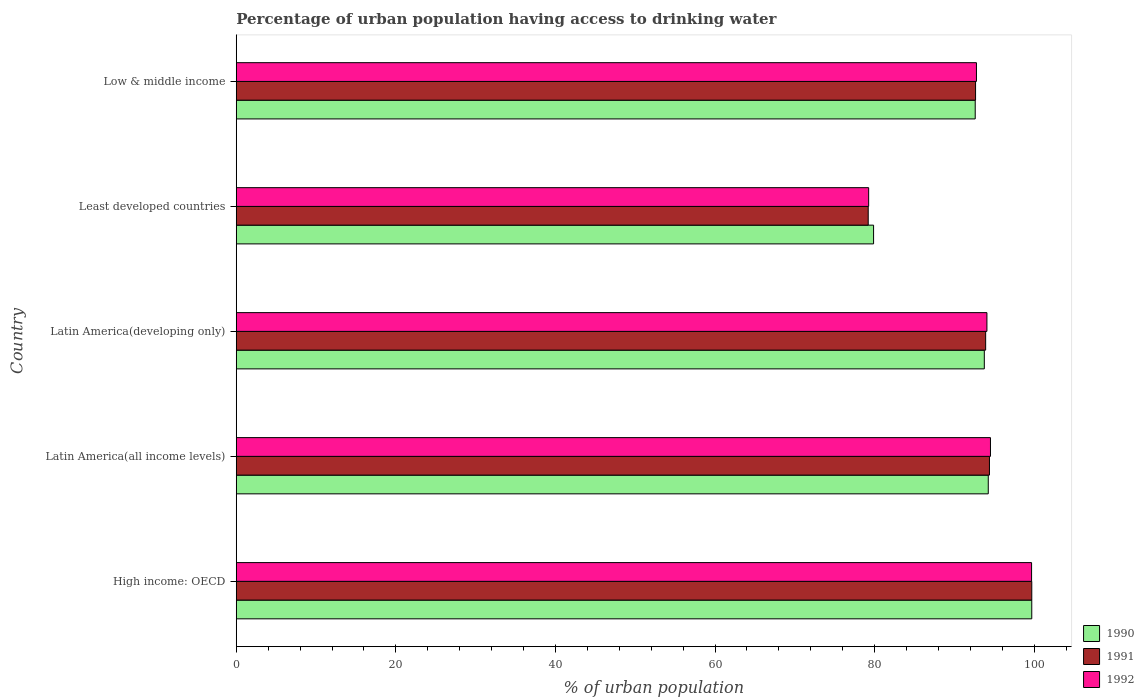How many different coloured bars are there?
Provide a short and direct response. 3. How many groups of bars are there?
Ensure brevity in your answer.  5. Are the number of bars on each tick of the Y-axis equal?
Provide a short and direct response. Yes. What is the label of the 2nd group of bars from the top?
Your answer should be compact. Least developed countries. In how many cases, is the number of bars for a given country not equal to the number of legend labels?
Ensure brevity in your answer.  0. What is the percentage of urban population having access to drinking water in 1990 in Latin America(developing only)?
Provide a succinct answer. 93.75. Across all countries, what is the maximum percentage of urban population having access to drinking water in 1992?
Give a very brief answer. 99.67. Across all countries, what is the minimum percentage of urban population having access to drinking water in 1990?
Ensure brevity in your answer.  79.87. In which country was the percentage of urban population having access to drinking water in 1992 maximum?
Offer a terse response. High income: OECD. In which country was the percentage of urban population having access to drinking water in 1990 minimum?
Offer a terse response. Least developed countries. What is the total percentage of urban population having access to drinking water in 1990 in the graph?
Your response must be concise. 460.16. What is the difference between the percentage of urban population having access to drinking water in 1990 in Latin America(developing only) and that in Least developed countries?
Give a very brief answer. 13.88. What is the difference between the percentage of urban population having access to drinking water in 1991 in Low & middle income and the percentage of urban population having access to drinking water in 1992 in Least developed countries?
Ensure brevity in your answer.  13.4. What is the average percentage of urban population having access to drinking water in 1990 per country?
Give a very brief answer. 92.03. What is the difference between the percentage of urban population having access to drinking water in 1992 and percentage of urban population having access to drinking water in 1991 in High income: OECD?
Your answer should be very brief. -0.02. What is the ratio of the percentage of urban population having access to drinking water in 1990 in High income: OECD to that in Least developed countries?
Make the answer very short. 1.25. Is the percentage of urban population having access to drinking water in 1992 in Latin America(all income levels) less than that in Latin America(developing only)?
Your answer should be very brief. No. What is the difference between the highest and the second highest percentage of urban population having access to drinking water in 1991?
Keep it short and to the point. 5.31. What is the difference between the highest and the lowest percentage of urban population having access to drinking water in 1990?
Give a very brief answer. 19.82. In how many countries, is the percentage of urban population having access to drinking water in 1990 greater than the average percentage of urban population having access to drinking water in 1990 taken over all countries?
Provide a succinct answer. 4. Is the sum of the percentage of urban population having access to drinking water in 1991 in High income: OECD and Least developed countries greater than the maximum percentage of urban population having access to drinking water in 1992 across all countries?
Give a very brief answer. Yes. What does the 1st bar from the top in Latin America(developing only) represents?
Give a very brief answer. 1992. What does the 1st bar from the bottom in High income: OECD represents?
Your answer should be very brief. 1990. What is the difference between two consecutive major ticks on the X-axis?
Give a very brief answer. 20. Are the values on the major ticks of X-axis written in scientific E-notation?
Ensure brevity in your answer.  No. Where does the legend appear in the graph?
Keep it short and to the point. Bottom right. How many legend labels are there?
Offer a very short reply. 3. How are the legend labels stacked?
Keep it short and to the point. Vertical. What is the title of the graph?
Your answer should be compact. Percentage of urban population having access to drinking water. What is the label or title of the X-axis?
Keep it short and to the point. % of urban population. What is the label or title of the Y-axis?
Offer a very short reply. Country. What is the % of urban population of 1990 in High income: OECD?
Make the answer very short. 99.69. What is the % of urban population in 1991 in High income: OECD?
Your answer should be very brief. 99.7. What is the % of urban population of 1992 in High income: OECD?
Your answer should be compact. 99.67. What is the % of urban population of 1990 in Latin America(all income levels)?
Provide a short and direct response. 94.24. What is the % of urban population of 1991 in Latin America(all income levels)?
Offer a very short reply. 94.39. What is the % of urban population in 1992 in Latin America(all income levels)?
Offer a very short reply. 94.52. What is the % of urban population of 1990 in Latin America(developing only)?
Make the answer very short. 93.75. What is the % of urban population in 1991 in Latin America(developing only)?
Your response must be concise. 93.92. What is the % of urban population in 1992 in Latin America(developing only)?
Provide a short and direct response. 94.07. What is the % of urban population of 1990 in Least developed countries?
Your answer should be very brief. 79.87. What is the % of urban population of 1991 in Least developed countries?
Offer a terse response. 79.2. What is the % of urban population in 1992 in Least developed countries?
Provide a succinct answer. 79.25. What is the % of urban population in 1990 in Low & middle income?
Give a very brief answer. 92.61. What is the % of urban population of 1991 in Low & middle income?
Your answer should be compact. 92.65. What is the % of urban population of 1992 in Low & middle income?
Provide a short and direct response. 92.76. Across all countries, what is the maximum % of urban population of 1990?
Give a very brief answer. 99.69. Across all countries, what is the maximum % of urban population of 1991?
Make the answer very short. 99.7. Across all countries, what is the maximum % of urban population of 1992?
Give a very brief answer. 99.67. Across all countries, what is the minimum % of urban population of 1990?
Your answer should be very brief. 79.87. Across all countries, what is the minimum % of urban population of 1991?
Make the answer very short. 79.2. Across all countries, what is the minimum % of urban population of 1992?
Make the answer very short. 79.25. What is the total % of urban population in 1990 in the graph?
Your response must be concise. 460.16. What is the total % of urban population in 1991 in the graph?
Keep it short and to the point. 459.85. What is the total % of urban population of 1992 in the graph?
Keep it short and to the point. 460.28. What is the difference between the % of urban population of 1990 in High income: OECD and that in Latin America(all income levels)?
Offer a very short reply. 5.45. What is the difference between the % of urban population of 1991 in High income: OECD and that in Latin America(all income levels)?
Your answer should be very brief. 5.31. What is the difference between the % of urban population in 1992 in High income: OECD and that in Latin America(all income levels)?
Give a very brief answer. 5.15. What is the difference between the % of urban population of 1990 in High income: OECD and that in Latin America(developing only)?
Make the answer very short. 5.95. What is the difference between the % of urban population in 1991 in High income: OECD and that in Latin America(developing only)?
Your answer should be compact. 5.78. What is the difference between the % of urban population of 1992 in High income: OECD and that in Latin America(developing only)?
Your response must be concise. 5.6. What is the difference between the % of urban population in 1990 in High income: OECD and that in Least developed countries?
Give a very brief answer. 19.82. What is the difference between the % of urban population in 1991 in High income: OECD and that in Least developed countries?
Offer a very short reply. 20.5. What is the difference between the % of urban population in 1992 in High income: OECD and that in Least developed countries?
Your answer should be compact. 20.42. What is the difference between the % of urban population of 1990 in High income: OECD and that in Low & middle income?
Ensure brevity in your answer.  7.09. What is the difference between the % of urban population of 1991 in High income: OECD and that in Low & middle income?
Your answer should be very brief. 7.05. What is the difference between the % of urban population in 1992 in High income: OECD and that in Low & middle income?
Make the answer very short. 6.91. What is the difference between the % of urban population of 1990 in Latin America(all income levels) and that in Latin America(developing only)?
Keep it short and to the point. 0.49. What is the difference between the % of urban population in 1991 in Latin America(all income levels) and that in Latin America(developing only)?
Provide a succinct answer. 0.47. What is the difference between the % of urban population in 1992 in Latin America(all income levels) and that in Latin America(developing only)?
Provide a short and direct response. 0.44. What is the difference between the % of urban population in 1990 in Latin America(all income levels) and that in Least developed countries?
Offer a terse response. 14.37. What is the difference between the % of urban population of 1991 in Latin America(all income levels) and that in Least developed countries?
Offer a very short reply. 15.19. What is the difference between the % of urban population of 1992 in Latin America(all income levels) and that in Least developed countries?
Offer a very short reply. 15.27. What is the difference between the % of urban population in 1990 in Latin America(all income levels) and that in Low & middle income?
Your answer should be very brief. 1.63. What is the difference between the % of urban population in 1991 in Latin America(all income levels) and that in Low & middle income?
Make the answer very short. 1.74. What is the difference between the % of urban population in 1992 in Latin America(all income levels) and that in Low & middle income?
Offer a terse response. 1.76. What is the difference between the % of urban population of 1990 in Latin America(developing only) and that in Least developed countries?
Offer a terse response. 13.88. What is the difference between the % of urban population of 1991 in Latin America(developing only) and that in Least developed countries?
Provide a short and direct response. 14.72. What is the difference between the % of urban population in 1992 in Latin America(developing only) and that in Least developed countries?
Offer a terse response. 14.82. What is the difference between the % of urban population of 1990 in Latin America(developing only) and that in Low & middle income?
Your answer should be compact. 1.14. What is the difference between the % of urban population of 1991 in Latin America(developing only) and that in Low & middle income?
Provide a succinct answer. 1.27. What is the difference between the % of urban population in 1992 in Latin America(developing only) and that in Low & middle income?
Give a very brief answer. 1.31. What is the difference between the % of urban population of 1990 in Least developed countries and that in Low & middle income?
Ensure brevity in your answer.  -12.74. What is the difference between the % of urban population in 1991 in Least developed countries and that in Low & middle income?
Provide a succinct answer. -13.45. What is the difference between the % of urban population of 1992 in Least developed countries and that in Low & middle income?
Give a very brief answer. -13.51. What is the difference between the % of urban population in 1990 in High income: OECD and the % of urban population in 1991 in Latin America(all income levels)?
Keep it short and to the point. 5.3. What is the difference between the % of urban population of 1990 in High income: OECD and the % of urban population of 1992 in Latin America(all income levels)?
Keep it short and to the point. 5.18. What is the difference between the % of urban population in 1991 in High income: OECD and the % of urban population in 1992 in Latin America(all income levels)?
Provide a succinct answer. 5.18. What is the difference between the % of urban population in 1990 in High income: OECD and the % of urban population in 1991 in Latin America(developing only)?
Your answer should be very brief. 5.78. What is the difference between the % of urban population of 1990 in High income: OECD and the % of urban population of 1992 in Latin America(developing only)?
Ensure brevity in your answer.  5.62. What is the difference between the % of urban population in 1991 in High income: OECD and the % of urban population in 1992 in Latin America(developing only)?
Your answer should be compact. 5.62. What is the difference between the % of urban population of 1990 in High income: OECD and the % of urban population of 1991 in Least developed countries?
Provide a succinct answer. 20.5. What is the difference between the % of urban population in 1990 in High income: OECD and the % of urban population in 1992 in Least developed countries?
Your answer should be compact. 20.44. What is the difference between the % of urban population in 1991 in High income: OECD and the % of urban population in 1992 in Least developed countries?
Your response must be concise. 20.44. What is the difference between the % of urban population of 1990 in High income: OECD and the % of urban population of 1991 in Low & middle income?
Keep it short and to the point. 7.04. What is the difference between the % of urban population in 1990 in High income: OECD and the % of urban population in 1992 in Low & middle income?
Make the answer very short. 6.93. What is the difference between the % of urban population in 1991 in High income: OECD and the % of urban population in 1992 in Low & middle income?
Provide a short and direct response. 6.93. What is the difference between the % of urban population of 1990 in Latin America(all income levels) and the % of urban population of 1991 in Latin America(developing only)?
Make the answer very short. 0.33. What is the difference between the % of urban population of 1990 in Latin America(all income levels) and the % of urban population of 1992 in Latin America(developing only)?
Provide a succinct answer. 0.17. What is the difference between the % of urban population of 1991 in Latin America(all income levels) and the % of urban population of 1992 in Latin America(developing only)?
Provide a succinct answer. 0.32. What is the difference between the % of urban population of 1990 in Latin America(all income levels) and the % of urban population of 1991 in Least developed countries?
Give a very brief answer. 15.04. What is the difference between the % of urban population in 1990 in Latin America(all income levels) and the % of urban population in 1992 in Least developed countries?
Make the answer very short. 14.99. What is the difference between the % of urban population in 1991 in Latin America(all income levels) and the % of urban population in 1992 in Least developed countries?
Give a very brief answer. 15.14. What is the difference between the % of urban population of 1990 in Latin America(all income levels) and the % of urban population of 1991 in Low & middle income?
Give a very brief answer. 1.59. What is the difference between the % of urban population of 1990 in Latin America(all income levels) and the % of urban population of 1992 in Low & middle income?
Your response must be concise. 1.48. What is the difference between the % of urban population of 1991 in Latin America(all income levels) and the % of urban population of 1992 in Low & middle income?
Ensure brevity in your answer.  1.63. What is the difference between the % of urban population in 1990 in Latin America(developing only) and the % of urban population in 1991 in Least developed countries?
Make the answer very short. 14.55. What is the difference between the % of urban population in 1990 in Latin America(developing only) and the % of urban population in 1992 in Least developed countries?
Make the answer very short. 14.5. What is the difference between the % of urban population in 1991 in Latin America(developing only) and the % of urban population in 1992 in Least developed countries?
Your answer should be very brief. 14.66. What is the difference between the % of urban population in 1990 in Latin America(developing only) and the % of urban population in 1991 in Low & middle income?
Make the answer very short. 1.1. What is the difference between the % of urban population of 1990 in Latin America(developing only) and the % of urban population of 1992 in Low & middle income?
Your answer should be compact. 0.99. What is the difference between the % of urban population of 1991 in Latin America(developing only) and the % of urban population of 1992 in Low & middle income?
Offer a very short reply. 1.15. What is the difference between the % of urban population of 1990 in Least developed countries and the % of urban population of 1991 in Low & middle income?
Your answer should be compact. -12.78. What is the difference between the % of urban population in 1990 in Least developed countries and the % of urban population in 1992 in Low & middle income?
Provide a short and direct response. -12.89. What is the difference between the % of urban population in 1991 in Least developed countries and the % of urban population in 1992 in Low & middle income?
Offer a very short reply. -13.56. What is the average % of urban population in 1990 per country?
Provide a succinct answer. 92.03. What is the average % of urban population of 1991 per country?
Offer a very short reply. 91.97. What is the average % of urban population in 1992 per country?
Ensure brevity in your answer.  92.06. What is the difference between the % of urban population of 1990 and % of urban population of 1991 in High income: OECD?
Your response must be concise. -0. What is the difference between the % of urban population in 1990 and % of urban population in 1992 in High income: OECD?
Provide a succinct answer. 0.02. What is the difference between the % of urban population of 1991 and % of urban population of 1992 in High income: OECD?
Provide a short and direct response. 0.02. What is the difference between the % of urban population of 1990 and % of urban population of 1991 in Latin America(all income levels)?
Provide a short and direct response. -0.15. What is the difference between the % of urban population of 1990 and % of urban population of 1992 in Latin America(all income levels)?
Ensure brevity in your answer.  -0.28. What is the difference between the % of urban population in 1991 and % of urban population in 1992 in Latin America(all income levels)?
Your response must be concise. -0.13. What is the difference between the % of urban population of 1990 and % of urban population of 1991 in Latin America(developing only)?
Provide a short and direct response. -0.17. What is the difference between the % of urban population in 1990 and % of urban population in 1992 in Latin America(developing only)?
Make the answer very short. -0.33. What is the difference between the % of urban population of 1991 and % of urban population of 1992 in Latin America(developing only)?
Your answer should be compact. -0.16. What is the difference between the % of urban population in 1990 and % of urban population in 1991 in Least developed countries?
Give a very brief answer. 0.67. What is the difference between the % of urban population in 1990 and % of urban population in 1992 in Least developed countries?
Your answer should be compact. 0.62. What is the difference between the % of urban population in 1991 and % of urban population in 1992 in Least developed countries?
Your response must be concise. -0.05. What is the difference between the % of urban population in 1990 and % of urban population in 1991 in Low & middle income?
Provide a short and direct response. -0.04. What is the difference between the % of urban population of 1990 and % of urban population of 1992 in Low & middle income?
Keep it short and to the point. -0.15. What is the difference between the % of urban population in 1991 and % of urban population in 1992 in Low & middle income?
Keep it short and to the point. -0.11. What is the ratio of the % of urban population of 1990 in High income: OECD to that in Latin America(all income levels)?
Keep it short and to the point. 1.06. What is the ratio of the % of urban population of 1991 in High income: OECD to that in Latin America(all income levels)?
Make the answer very short. 1.06. What is the ratio of the % of urban population in 1992 in High income: OECD to that in Latin America(all income levels)?
Give a very brief answer. 1.05. What is the ratio of the % of urban population of 1990 in High income: OECD to that in Latin America(developing only)?
Make the answer very short. 1.06. What is the ratio of the % of urban population in 1991 in High income: OECD to that in Latin America(developing only)?
Your response must be concise. 1.06. What is the ratio of the % of urban population in 1992 in High income: OECD to that in Latin America(developing only)?
Your answer should be very brief. 1.06. What is the ratio of the % of urban population in 1990 in High income: OECD to that in Least developed countries?
Keep it short and to the point. 1.25. What is the ratio of the % of urban population in 1991 in High income: OECD to that in Least developed countries?
Keep it short and to the point. 1.26. What is the ratio of the % of urban population in 1992 in High income: OECD to that in Least developed countries?
Provide a succinct answer. 1.26. What is the ratio of the % of urban population of 1990 in High income: OECD to that in Low & middle income?
Your answer should be very brief. 1.08. What is the ratio of the % of urban population in 1991 in High income: OECD to that in Low & middle income?
Ensure brevity in your answer.  1.08. What is the ratio of the % of urban population of 1992 in High income: OECD to that in Low & middle income?
Ensure brevity in your answer.  1.07. What is the ratio of the % of urban population in 1991 in Latin America(all income levels) to that in Latin America(developing only)?
Your answer should be compact. 1.01. What is the ratio of the % of urban population in 1992 in Latin America(all income levels) to that in Latin America(developing only)?
Provide a short and direct response. 1. What is the ratio of the % of urban population in 1990 in Latin America(all income levels) to that in Least developed countries?
Your answer should be very brief. 1.18. What is the ratio of the % of urban population of 1991 in Latin America(all income levels) to that in Least developed countries?
Ensure brevity in your answer.  1.19. What is the ratio of the % of urban population of 1992 in Latin America(all income levels) to that in Least developed countries?
Make the answer very short. 1.19. What is the ratio of the % of urban population of 1990 in Latin America(all income levels) to that in Low & middle income?
Offer a terse response. 1.02. What is the ratio of the % of urban population in 1991 in Latin America(all income levels) to that in Low & middle income?
Your answer should be compact. 1.02. What is the ratio of the % of urban population in 1992 in Latin America(all income levels) to that in Low & middle income?
Your response must be concise. 1.02. What is the ratio of the % of urban population in 1990 in Latin America(developing only) to that in Least developed countries?
Provide a short and direct response. 1.17. What is the ratio of the % of urban population in 1991 in Latin America(developing only) to that in Least developed countries?
Give a very brief answer. 1.19. What is the ratio of the % of urban population of 1992 in Latin America(developing only) to that in Least developed countries?
Your answer should be very brief. 1.19. What is the ratio of the % of urban population of 1990 in Latin America(developing only) to that in Low & middle income?
Offer a terse response. 1.01. What is the ratio of the % of urban population of 1991 in Latin America(developing only) to that in Low & middle income?
Give a very brief answer. 1.01. What is the ratio of the % of urban population of 1992 in Latin America(developing only) to that in Low & middle income?
Offer a terse response. 1.01. What is the ratio of the % of urban population in 1990 in Least developed countries to that in Low & middle income?
Provide a succinct answer. 0.86. What is the ratio of the % of urban population in 1991 in Least developed countries to that in Low & middle income?
Offer a terse response. 0.85. What is the ratio of the % of urban population in 1992 in Least developed countries to that in Low & middle income?
Offer a terse response. 0.85. What is the difference between the highest and the second highest % of urban population of 1990?
Offer a terse response. 5.45. What is the difference between the highest and the second highest % of urban population of 1991?
Ensure brevity in your answer.  5.31. What is the difference between the highest and the second highest % of urban population of 1992?
Provide a short and direct response. 5.15. What is the difference between the highest and the lowest % of urban population in 1990?
Keep it short and to the point. 19.82. What is the difference between the highest and the lowest % of urban population of 1991?
Ensure brevity in your answer.  20.5. What is the difference between the highest and the lowest % of urban population in 1992?
Provide a succinct answer. 20.42. 